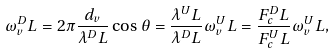Convert formula to latex. <formula><loc_0><loc_0><loc_500><loc_500>\omega _ { v } ^ { D } L = 2 \pi \frac { d _ { v } } { \lambda ^ { D } L } \cos { \theta } = \frac { \lambda ^ { U } L } { \lambda ^ { D } L } \omega _ { v } ^ { U } L = \frac { F _ { c } ^ { D } L } { F _ { c } ^ { U } L } \omega _ { v } ^ { U } L ,</formula> 